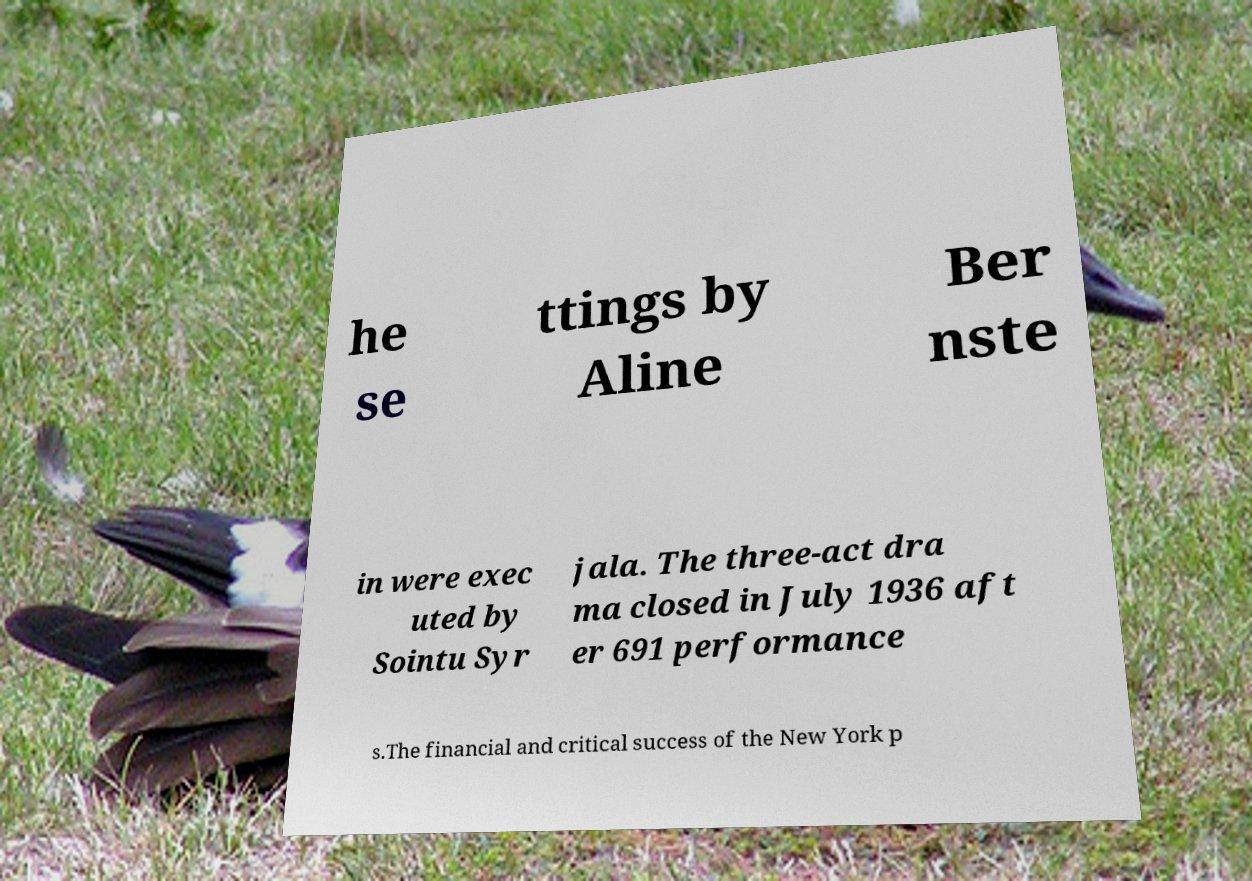Can you accurately transcribe the text from the provided image for me? he se ttings by Aline Ber nste in were exec uted by Sointu Syr jala. The three-act dra ma closed in July 1936 aft er 691 performance s.The financial and critical success of the New York p 